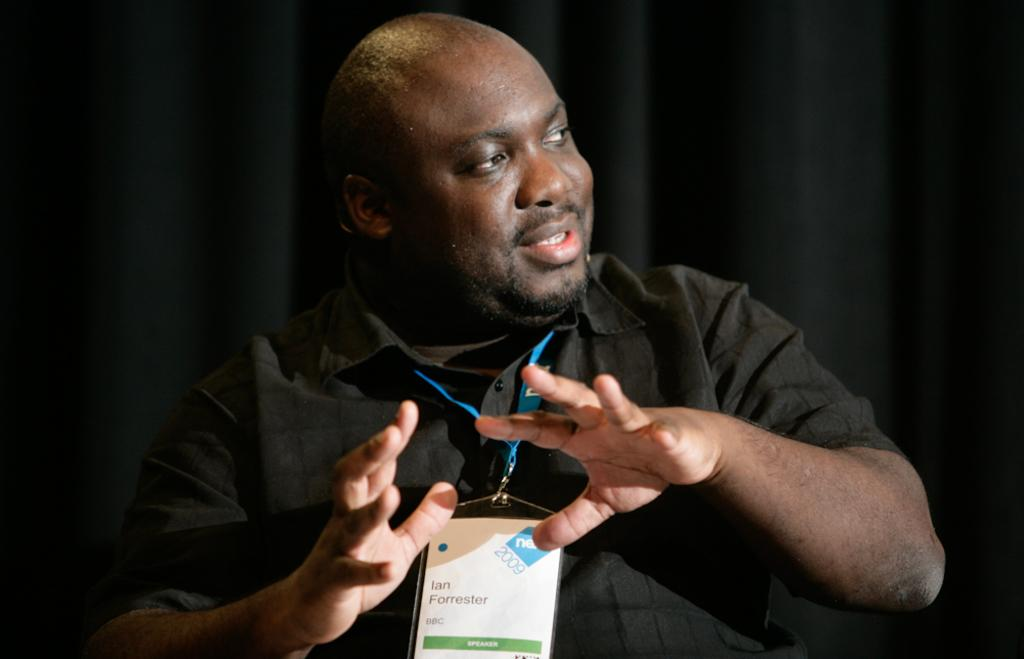Who is present in the image? There is a man in the image. What is the man wearing? The man is wearing black clothes. Does the man have any identification in the image? Yes, the man has an identity card. What is the man's facial expression in the image? The man is smiling. What can be seen in the background of the image? There are black curtains in the background of the image. What type of zephyr is blowing through the man's hair in the image? There is no zephyr present in the image; it is a still photograph. What power source is being used to create the man's smile in the image? The man's smile is genuine and not created by any power source. 